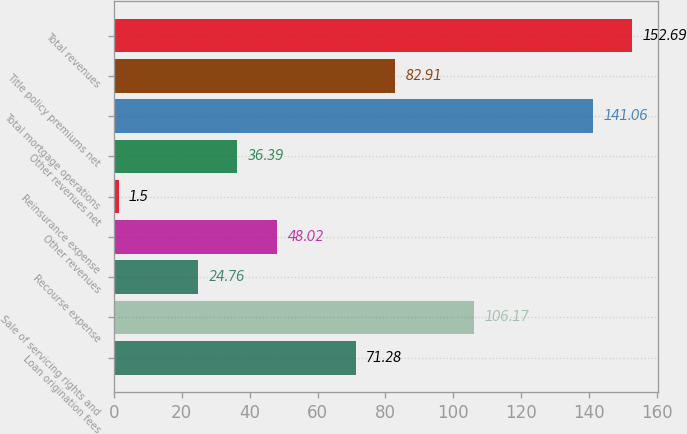Convert chart to OTSL. <chart><loc_0><loc_0><loc_500><loc_500><bar_chart><fcel>Loan origination fees<fcel>Sale of servicing rights and<fcel>Recourse expense<fcel>Other revenues<fcel>Reinsurance expense<fcel>Other revenues net<fcel>Total mortgage operations<fcel>Title policy premiums net<fcel>Total revenues<nl><fcel>71.28<fcel>106.17<fcel>24.76<fcel>48.02<fcel>1.5<fcel>36.39<fcel>141.06<fcel>82.91<fcel>152.69<nl></chart> 